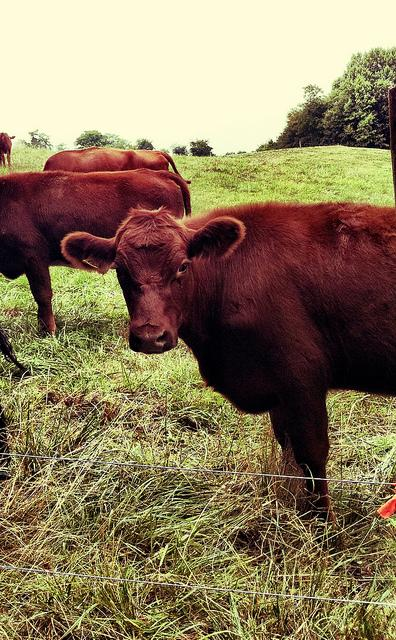What has the big ears?

Choices:
A) cat
B) cow
C) baby
D) elephant cow 